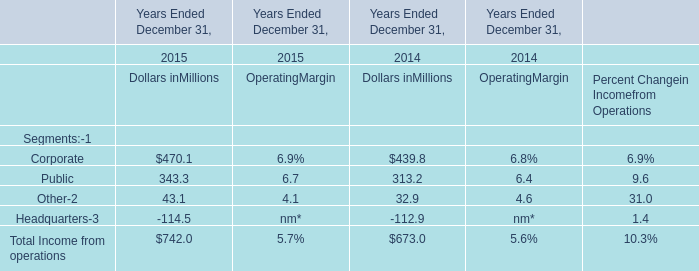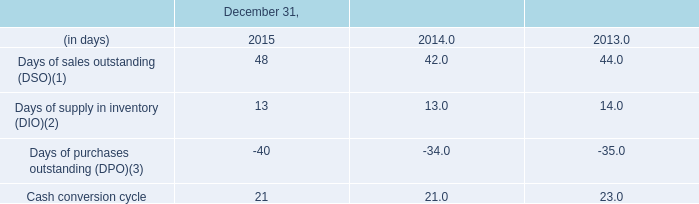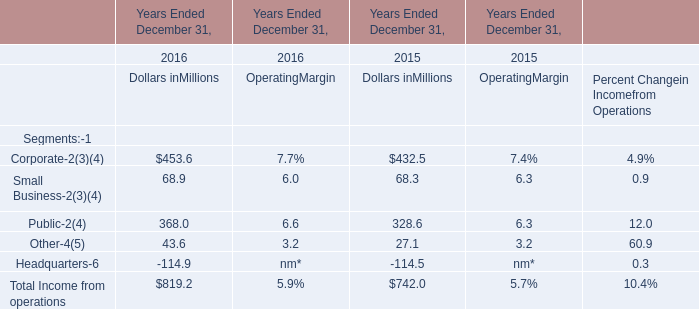from dec 31 , 2013 to dec 31 , 2014 , what was the percentage decrease in the length of the cash conversion cycle? 
Computations: (((23 - 21) / 21) * 100)
Answer: 9.52381. 